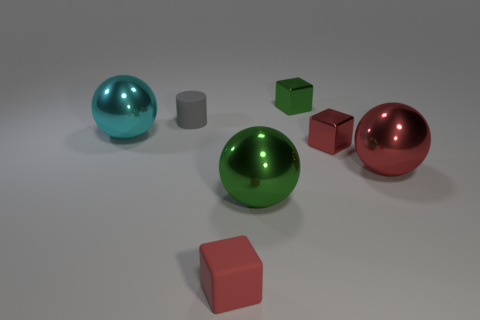There is a large metal object to the right of the green block; are there any red metal spheres that are in front of it?
Ensure brevity in your answer.  No. What number of green balls have the same material as the small green thing?
Your answer should be compact. 1. Are there any small green objects?
Your response must be concise. Yes. How many large objects have the same color as the matte block?
Your answer should be compact. 1. Do the tiny green block and the ball that is on the right side of the green cube have the same material?
Ensure brevity in your answer.  Yes. Is the number of big red metal balls in front of the tiny green shiny object greater than the number of small green metal cylinders?
Make the answer very short. Yes. There is a tiny matte cylinder; is it the same color as the large metallic thing that is on the right side of the tiny green block?
Your answer should be compact. No. Are there the same number of cyan metallic spheres that are in front of the large red shiny object and cyan objects to the right of the red rubber thing?
Provide a short and direct response. Yes. There is a small red object that is in front of the big red shiny thing; what is its material?
Keep it short and to the point. Rubber. What number of objects are big balls that are in front of the big cyan metal thing or large cyan balls?
Your answer should be compact. 3. 